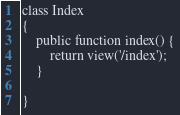Convert code to text. <code><loc_0><loc_0><loc_500><loc_500><_PHP_>
class Index
{
    public function index() {
        return view('/index');
    }

}</code> 